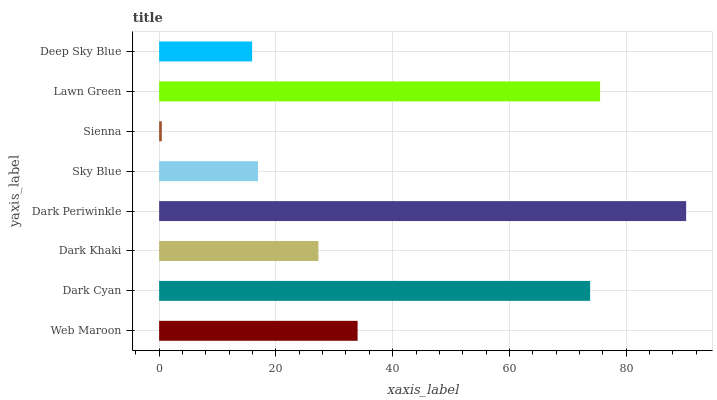Is Sienna the minimum?
Answer yes or no. Yes. Is Dark Periwinkle the maximum?
Answer yes or no. Yes. Is Dark Cyan the minimum?
Answer yes or no. No. Is Dark Cyan the maximum?
Answer yes or no. No. Is Dark Cyan greater than Web Maroon?
Answer yes or no. Yes. Is Web Maroon less than Dark Cyan?
Answer yes or no. Yes. Is Web Maroon greater than Dark Cyan?
Answer yes or no. No. Is Dark Cyan less than Web Maroon?
Answer yes or no. No. Is Web Maroon the high median?
Answer yes or no. Yes. Is Dark Khaki the low median?
Answer yes or no. Yes. Is Lawn Green the high median?
Answer yes or no. No. Is Dark Cyan the low median?
Answer yes or no. No. 